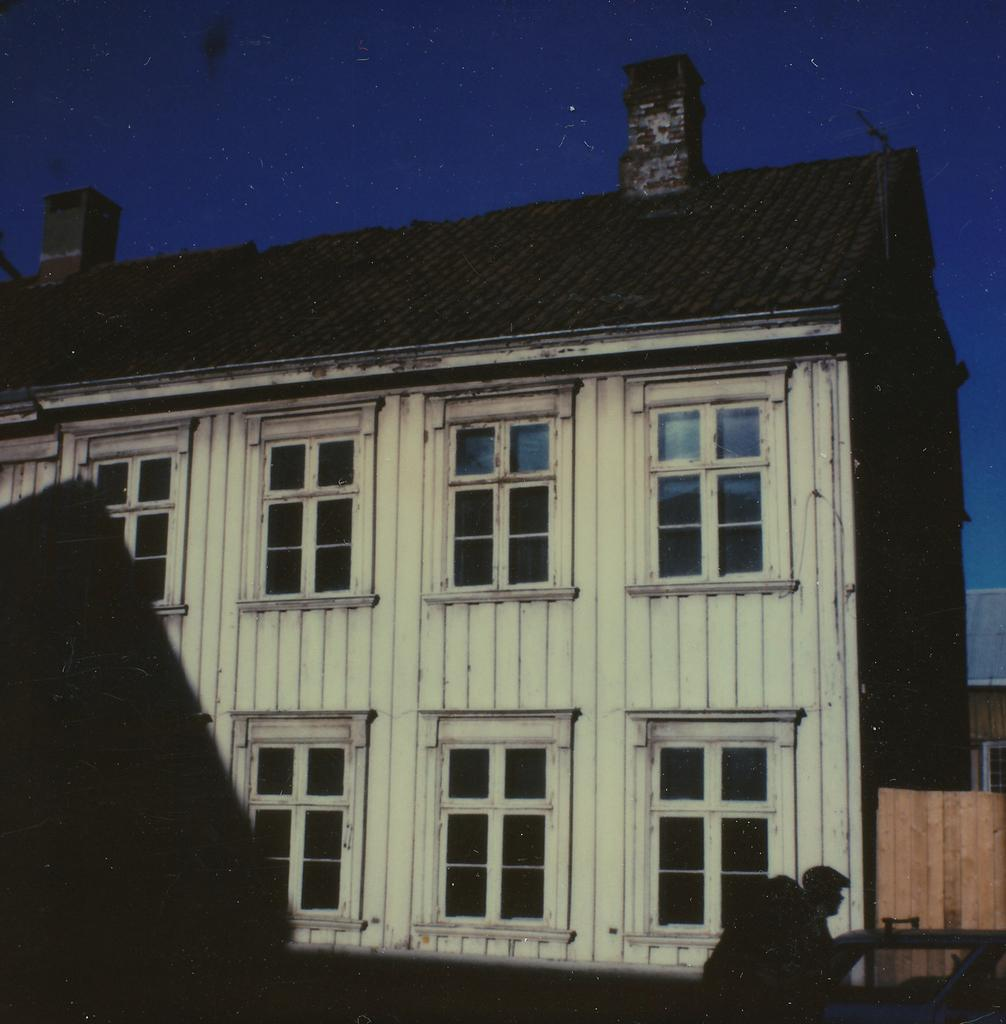What type of structure is in the picture? There is a house in the picture. What features can be seen on the house? The house has windows. Can you describe anything else related to the house in the picture? There is a shadow of a man on the house. What can be seen in the background of the picture? The sky is visible in the background of the picture. What type of story is being told by the owl in the picture? There is no owl present in the picture, so no story can be told by an owl. How many snakes are slithering around the house in the picture? There are no snakes present in the picture; the only living thing mentioned is the shadow of a man. 